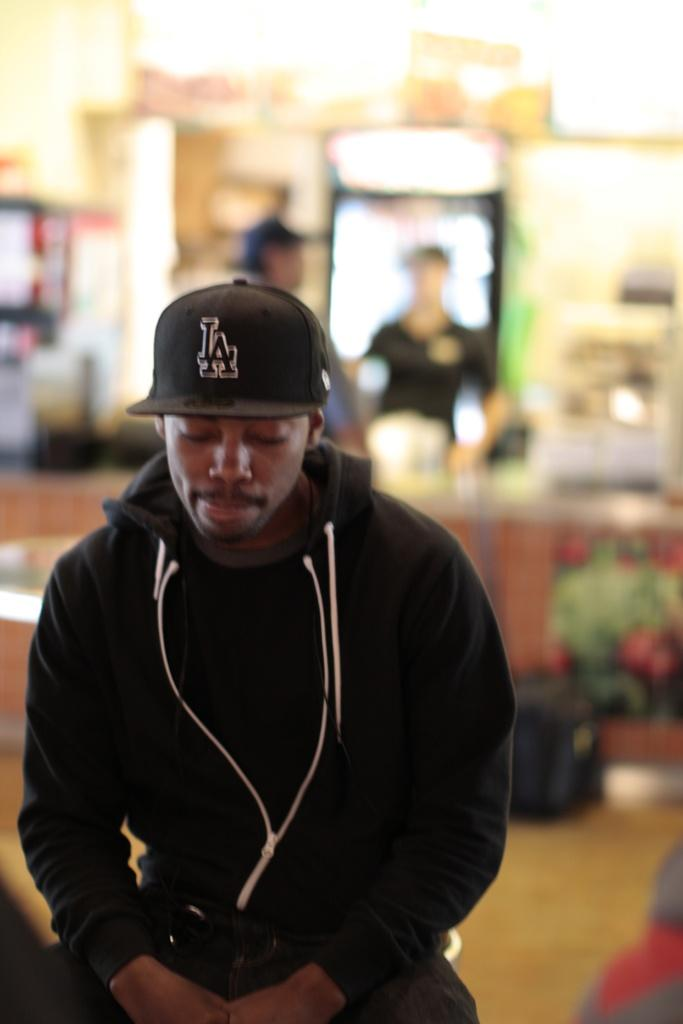What is the main subject of the image? There is a man in the image. What is the man wearing on his upper body? The man is wearing a black t-shirt and a jacket. What type of headwear is the man wearing? The man is wearing a cap. Can you describe the background of the image? There are two men in the background of the image. How many balls are being juggled by the pigs in the image? There are no pigs or balls present in the image. What level of expertise does the beginner have in the image? There is no reference to a beginner or any skill level in the image. 